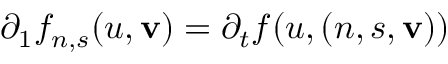Convert formula to latex. <formula><loc_0><loc_0><loc_500><loc_500>\partial _ { 1 } f _ { n , s } ( u , v ) = \partial _ { t } f ( u , ( n , s , v ) )</formula> 